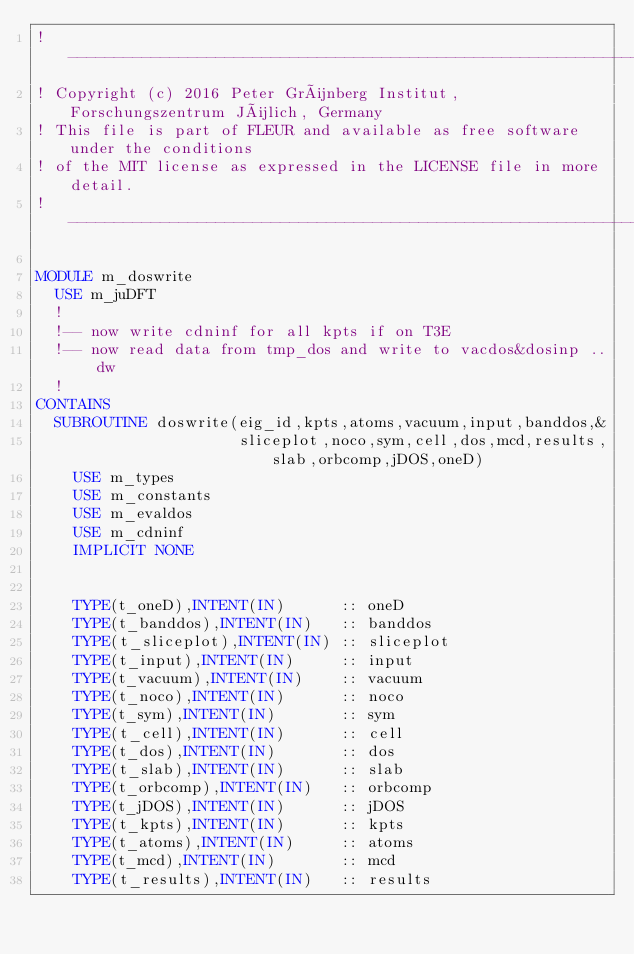Convert code to text. <code><loc_0><loc_0><loc_500><loc_500><_FORTRAN_>!--------------------------------------------------------------------------------
! Copyright (c) 2016 Peter Grünberg Institut, Forschungszentrum Jülich, Germany
! This file is part of FLEUR and available as free software under the conditions
! of the MIT license as expressed in the LICENSE file in more detail.
!--------------------------------------------------------------------------------

MODULE m_doswrite
  USE m_juDFT
  !
  !-- now write cdninf for all kpts if on T3E
  !-- now read data from tmp_dos and write to vacdos&dosinp .. dw
  !
CONTAINS
  SUBROUTINE doswrite(eig_id,kpts,atoms,vacuum,input,banddos,&
                      sliceplot,noco,sym,cell,dos,mcd,results,slab,orbcomp,jDOS,oneD)
    USE m_types
    USE m_constants
    USE m_evaldos
    USE m_cdninf
    IMPLICIT NONE
  
    
    TYPE(t_oneD),INTENT(IN)      :: oneD
    TYPE(t_banddos),INTENT(IN)   :: banddos
    TYPE(t_sliceplot),INTENT(IN) :: sliceplot
    TYPE(t_input),INTENT(IN)     :: input
    TYPE(t_vacuum),INTENT(IN)    :: vacuum
    TYPE(t_noco),INTENT(IN)      :: noco
    TYPE(t_sym),INTENT(IN)       :: sym
    TYPE(t_cell),INTENT(IN)      :: cell
    TYPE(t_dos),INTENT(IN)       :: dos
    TYPE(t_slab),INTENT(IN)      :: slab
    TYPE(t_orbcomp),INTENT(IN)   :: orbcomp
    TYPE(t_jDOS),INTENT(IN)      :: jDOS
    TYPE(t_kpts),INTENT(IN)      :: kpts
    TYPE(t_atoms),INTENT(IN)     :: atoms
    TYPE(t_mcd),INTENT(IN)       :: mcd
    TYPE(t_results),INTENT(IN)   :: results
</code> 